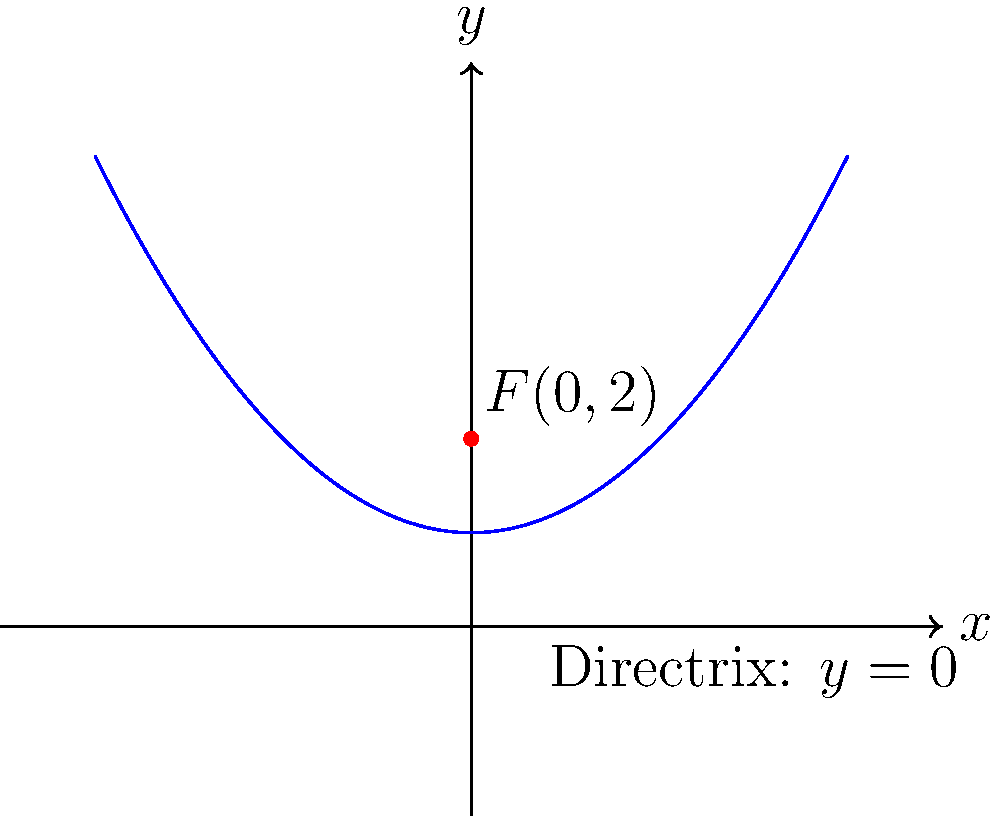As a watercolor artist, you often find inspiration in curved shapes. Consider the parabola shown in the coordinate plane above, which resembles a graceful ceramic vase. The focus of this parabola is at point $F(0,2)$, and its directrix is the x-axis $(y=0)$. What is the equation of this parabola? To find the equation of the parabola, we'll follow these steps:

1) The general equation of a parabola with a vertical axis of symmetry is:
   $$(x-h)^2 = 4p(y-k)$$
   where $(h,k)$ is the vertex and $p$ is the distance from the vertex to the focus.

2) The distance from the focus to the directrix is $2p$. Here, the focus is at $(0,2)$ and the directrix is at $y=0$, so:
   $2p = 2 - 0 = 2$
   $p = 1$

3) The vertex is halfway between the focus and the directrix:
   $k = \frac{2 + 0}{2} = 1$

4) The axis of symmetry passes through the focus, so $h = 0$.

5) Substituting these values into the general equation:
   $(x-0)^2 = 4(1)(y-1)$

6) Simplifying:
   $x^2 = 4(y-1)$
   $x^2 = 4y - 4$

7) Rearranging to standard form:
   $y = \frac{1}{4}x^2 + 1$

This equation represents the parabola that opens upward, with its vertex at $(0,1)$ and focus at $(0,2)$, just like in our artistic ceramic vase inspiration.
Answer: $y = \frac{1}{4}x^2 + 1$ 